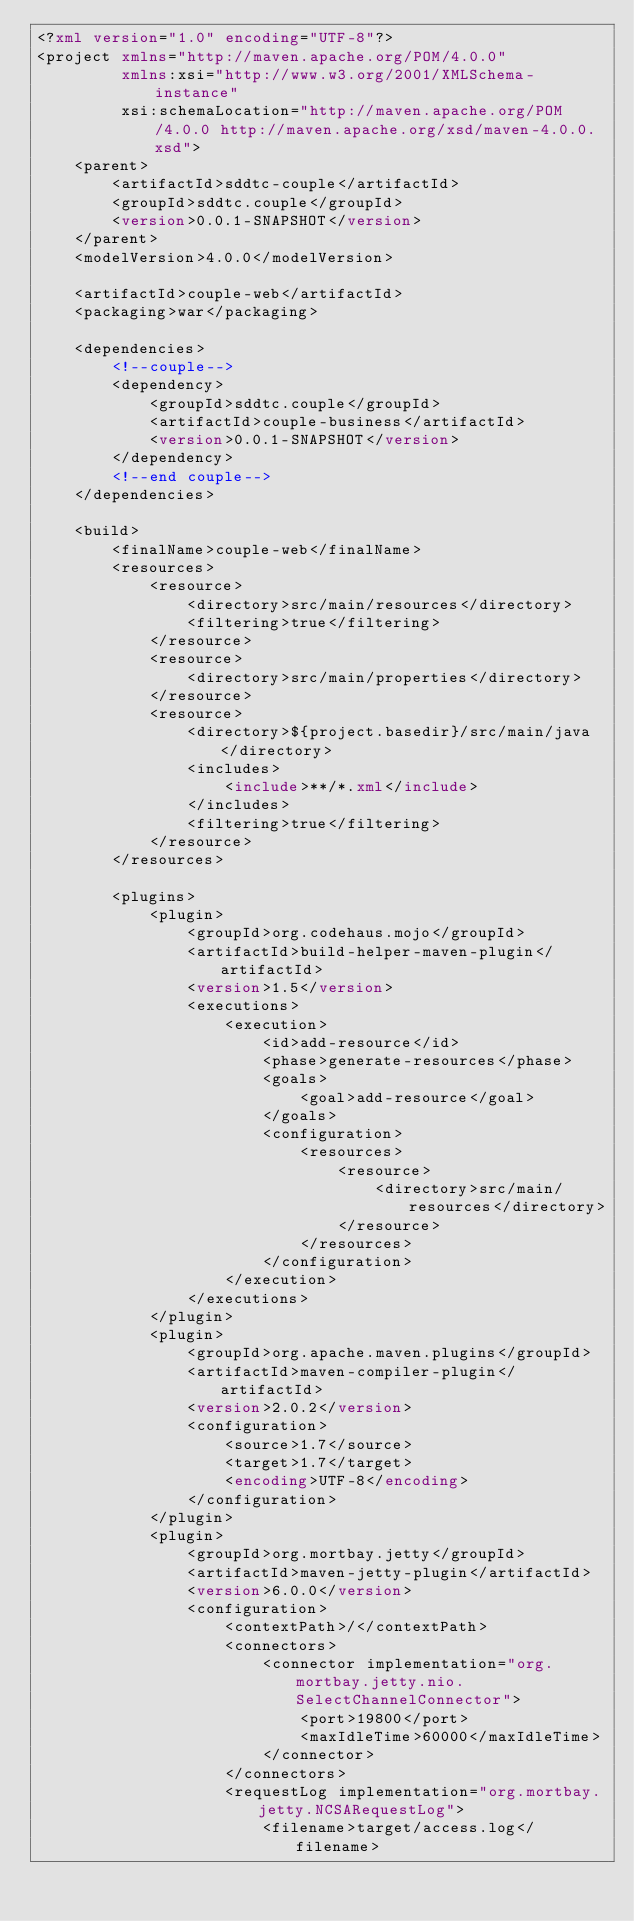Convert code to text. <code><loc_0><loc_0><loc_500><loc_500><_XML_><?xml version="1.0" encoding="UTF-8"?>
<project xmlns="http://maven.apache.org/POM/4.0.0"
         xmlns:xsi="http://www.w3.org/2001/XMLSchema-instance"
         xsi:schemaLocation="http://maven.apache.org/POM/4.0.0 http://maven.apache.org/xsd/maven-4.0.0.xsd">
    <parent>
        <artifactId>sddtc-couple</artifactId>
        <groupId>sddtc.couple</groupId>
        <version>0.0.1-SNAPSHOT</version>
    </parent>
    <modelVersion>4.0.0</modelVersion>

    <artifactId>couple-web</artifactId>
    <packaging>war</packaging>

    <dependencies>
        <!--couple-->
        <dependency>
            <groupId>sddtc.couple</groupId>
            <artifactId>couple-business</artifactId>
            <version>0.0.1-SNAPSHOT</version>
        </dependency>
        <!--end couple-->
    </dependencies>

    <build>
        <finalName>couple-web</finalName>
        <resources>
            <resource>
                <directory>src/main/resources</directory>
                <filtering>true</filtering>
            </resource>
            <resource>
                <directory>src/main/properties</directory>
            </resource>
            <resource>
                <directory>${project.basedir}/src/main/java</directory>
                <includes>
                    <include>**/*.xml</include>
                </includes>
                <filtering>true</filtering>
            </resource>
        </resources>

        <plugins>
            <plugin>
                <groupId>org.codehaus.mojo</groupId>
                <artifactId>build-helper-maven-plugin</artifactId>
                <version>1.5</version>
                <executions>
                    <execution>
                        <id>add-resource</id>
                        <phase>generate-resources</phase>
                        <goals>
                            <goal>add-resource</goal>
                        </goals>
                        <configuration>
                            <resources>
                                <resource>
                                    <directory>src/main/resources</directory>
                                </resource>
                            </resources>
                        </configuration>
                    </execution>
                </executions>
            </plugin>
            <plugin>
                <groupId>org.apache.maven.plugins</groupId>
                <artifactId>maven-compiler-plugin</artifactId>
                <version>2.0.2</version>
                <configuration>
                    <source>1.7</source>
                    <target>1.7</target>
                    <encoding>UTF-8</encoding>
                </configuration>
            </plugin>
            <plugin>
                <groupId>org.mortbay.jetty</groupId>
                <artifactId>maven-jetty-plugin</artifactId>
                <version>6.0.0</version>
                <configuration>
                    <contextPath>/</contextPath>
                    <connectors>
                        <connector implementation="org.mortbay.jetty.nio.SelectChannelConnector">
                            <port>19800</port>
                            <maxIdleTime>60000</maxIdleTime>
                        </connector>
                    </connectors>
                    <requestLog implementation="org.mortbay.jetty.NCSARequestLog">
                        <filename>target/access.log</filename></code> 